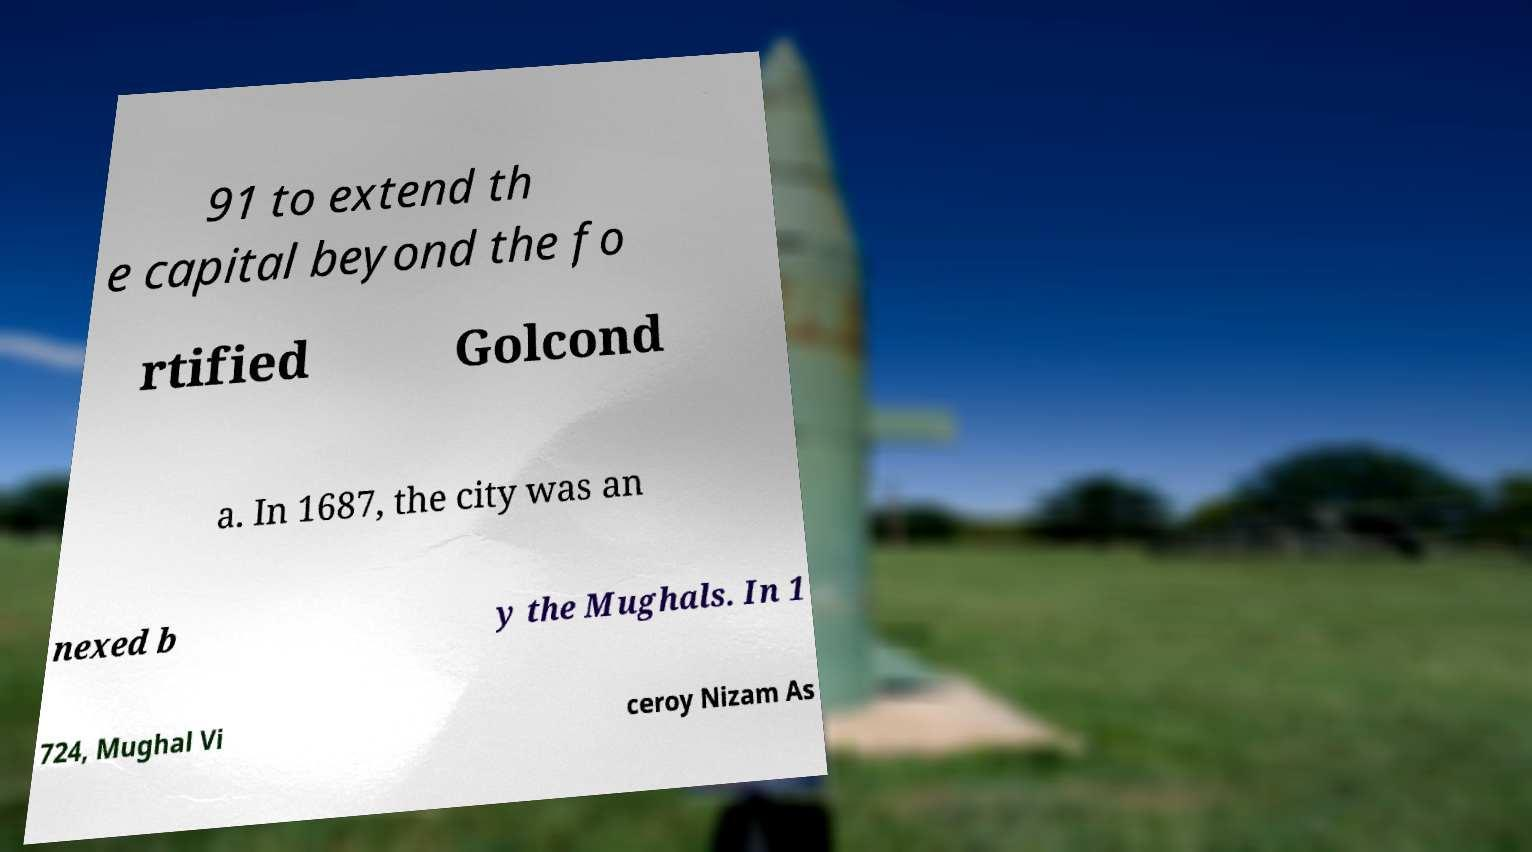There's text embedded in this image that I need extracted. Can you transcribe it verbatim? 91 to extend th e capital beyond the fo rtified Golcond a. In 1687, the city was an nexed b y the Mughals. In 1 724, Mughal Vi ceroy Nizam As 